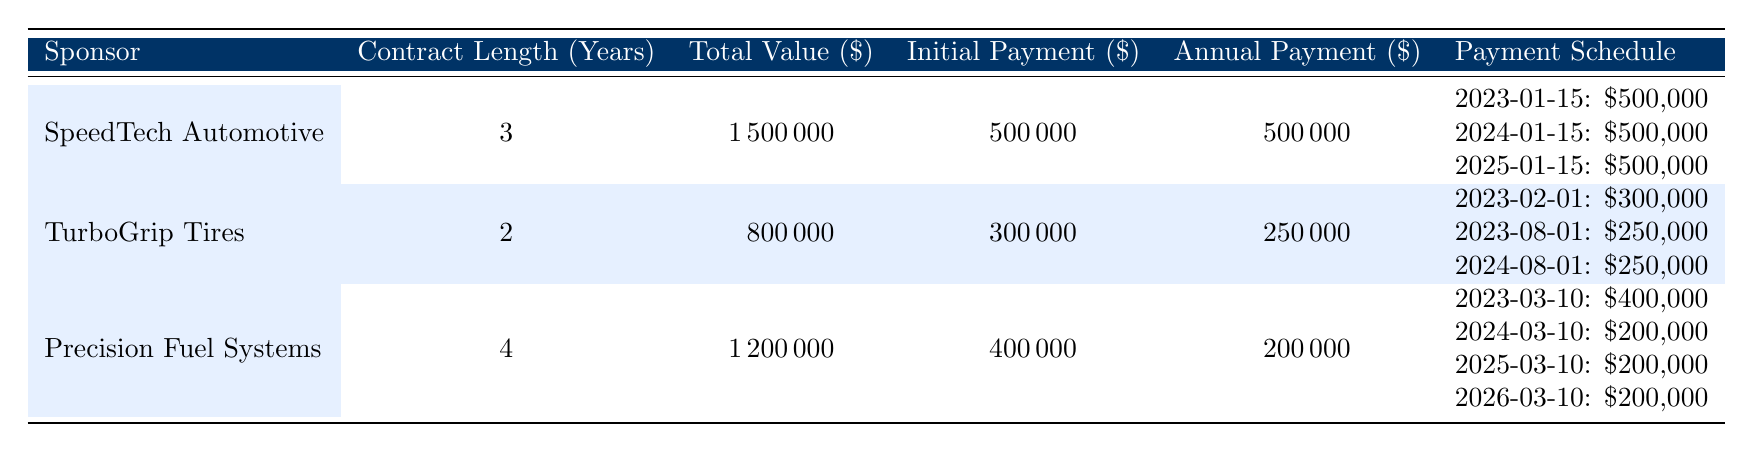What is the total value of the sponsorship from SpeedTech Automotive? The total value of SpeedTech Automotive's sponsorship is listed in the table under the "Total Value" column, which is shown as $1,500,000.
Answer: $1,500,000 How many years is the contract length for TurboGrip Tires? In the table, the "Contract Length (Years)" column shows TurboGrip Tires has a contract length of 2 years.
Answer: 2 years What is the total amount of annual payments expected from Precision Fuel Systems over the contract duration? Precision Fuel Systems has a contract length of 4 years with annual payments of $200,000 each for 3 years, plus an initial payment of $400,000. Therefore, the total annual payments are $200,000 * 3 = $600,000.
Answer: $600,000 Did SpeedTech Automotive make any payments in the first season? Yes, according to the payment schedule for SpeedTech Automotive, there is a payment of $500,000 due on January 15, 2023, which confirms that a payment was made in the first season.
Answer: Yes What is the average annual payment across all sponsors? To find the average, we calculate the total annual payments for each sponsor: SpeedTech Automotive has $500,000 per year for 3 years ($500,000 * 3 = $1,500,000), TurboGrip Tires has $250,000 for 2 years and additional $300,000 in the first year ($250,000 + $300,000 = $550,000). Precision Fuel Systems has $200,000 for 4 years ($200,000 * 4 = $800,000). The total payment amounts to $1,500,000 + $550,000 + $800,000 = $2,850,000 over 9 payment instances. The average annual payment is $2,850,000 / 9 = $316,667.
Answer: $316,667 How much more did TurboGrip Tires receive in the initial payment compared to the annual payment for the second season? TurboGrip Tires received an initial payment of $300,000, while the payment due for the second season is $250,000. To find the difference, we calculate $300,000 - $250,000 = $50,000.
Answer: $50,000 